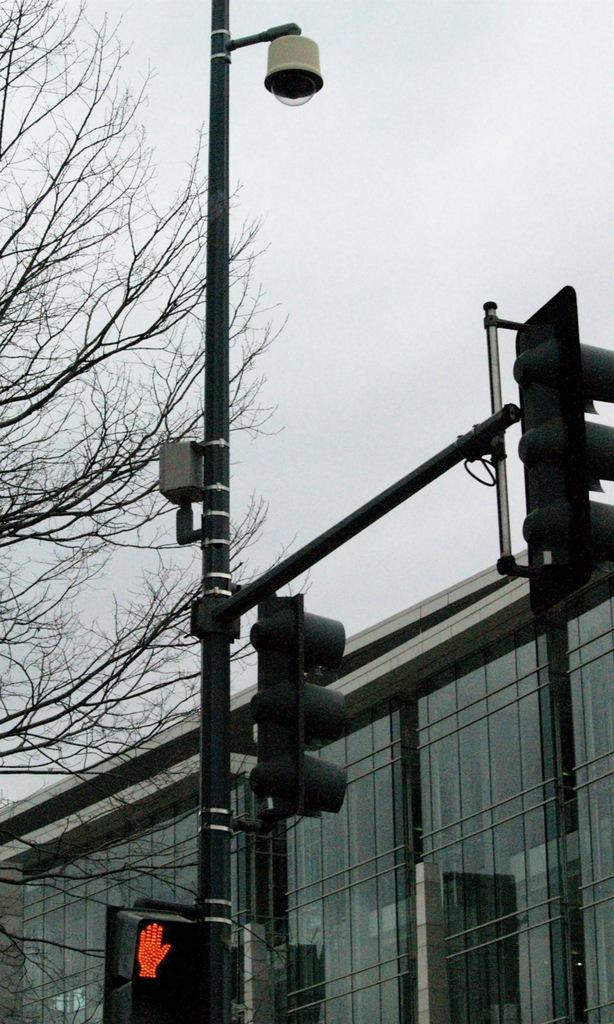What can be seen on the poles in the image? There are poles with traffic signals in the image. What additional feature is present on the pole? There is a CCTV camera on the pole. What type of building can be seen in the background of the image? There is a glass building in the background of the image. What natural element is visible in the background of the image? There is a tree in the background of the image. What is visible above the buildings and trees in the image? The sky is visible in the background of the image. What type of cart is being used to transport the hammer in the image? There is no cart or hammer present in the image. What thought is being expressed by the traffic signals in the image? Traffic signals do not express thoughts; they provide information to drivers. 